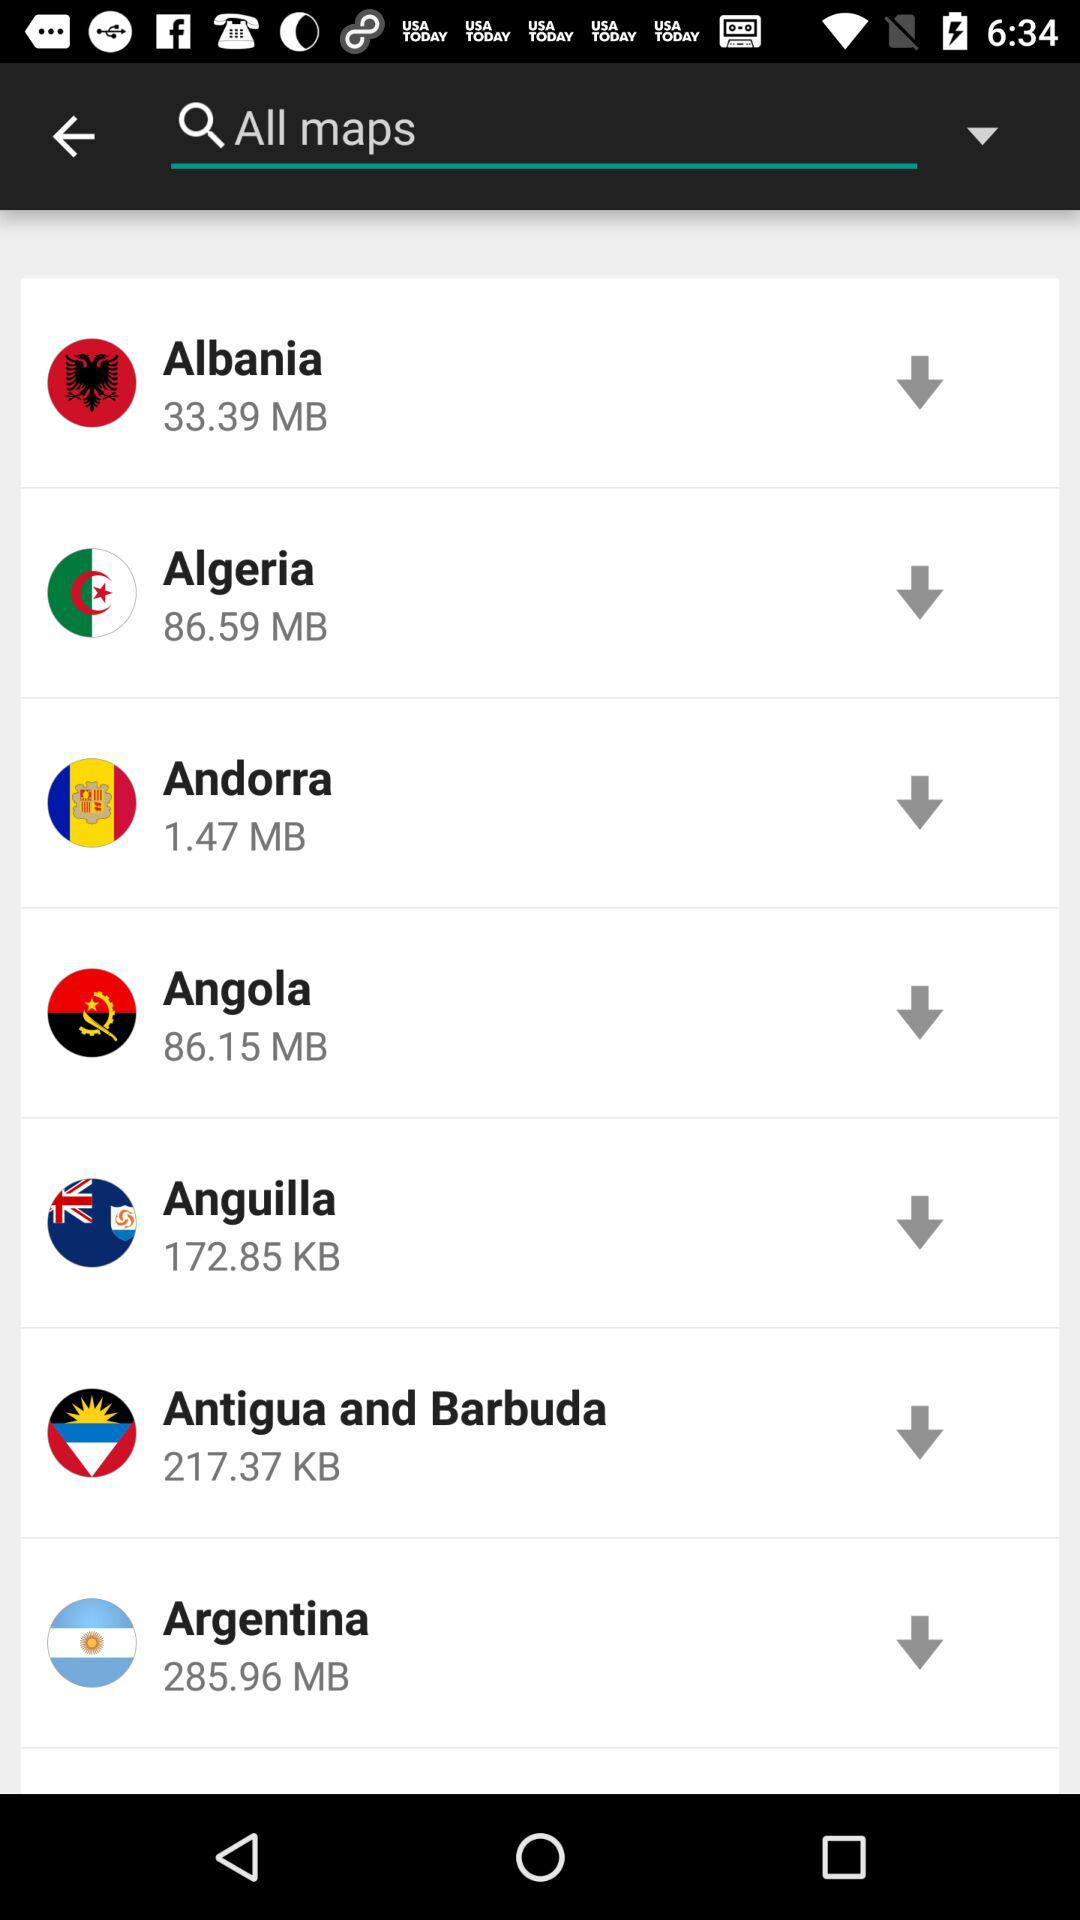What is the exact size of the "Albania" file? The exact size of the "Albania" file is 33.39 MB. 